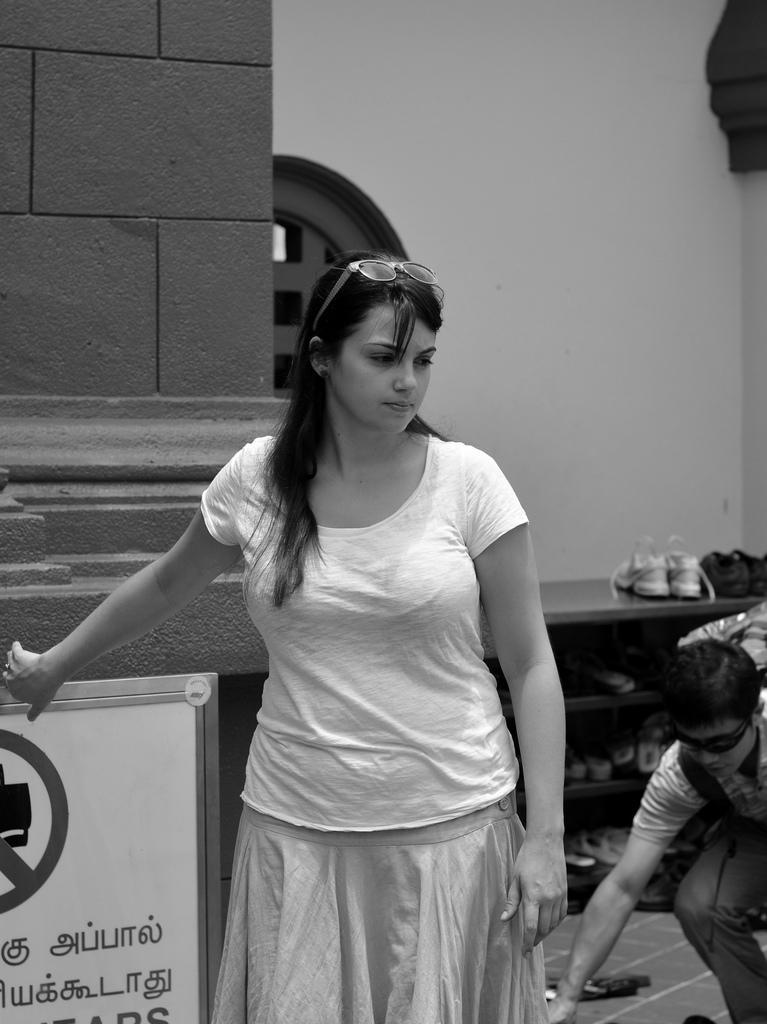How would you summarize this image in a sentence or two? It is a black and white image. In this image, we can see a woman is standing. On the left side, we can see a wall and board with some text and figure. On the right side we can see a person wearing goggles and backpack. Here there is a shelf and wall. On the tracks, we can see footwear. 